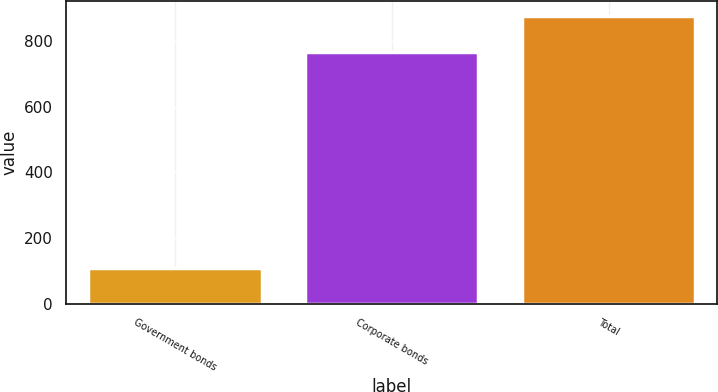<chart> <loc_0><loc_0><loc_500><loc_500><bar_chart><fcel>Government bonds<fcel>Corporate bonds<fcel>Total<nl><fcel>109<fcel>767<fcel>876<nl></chart> 